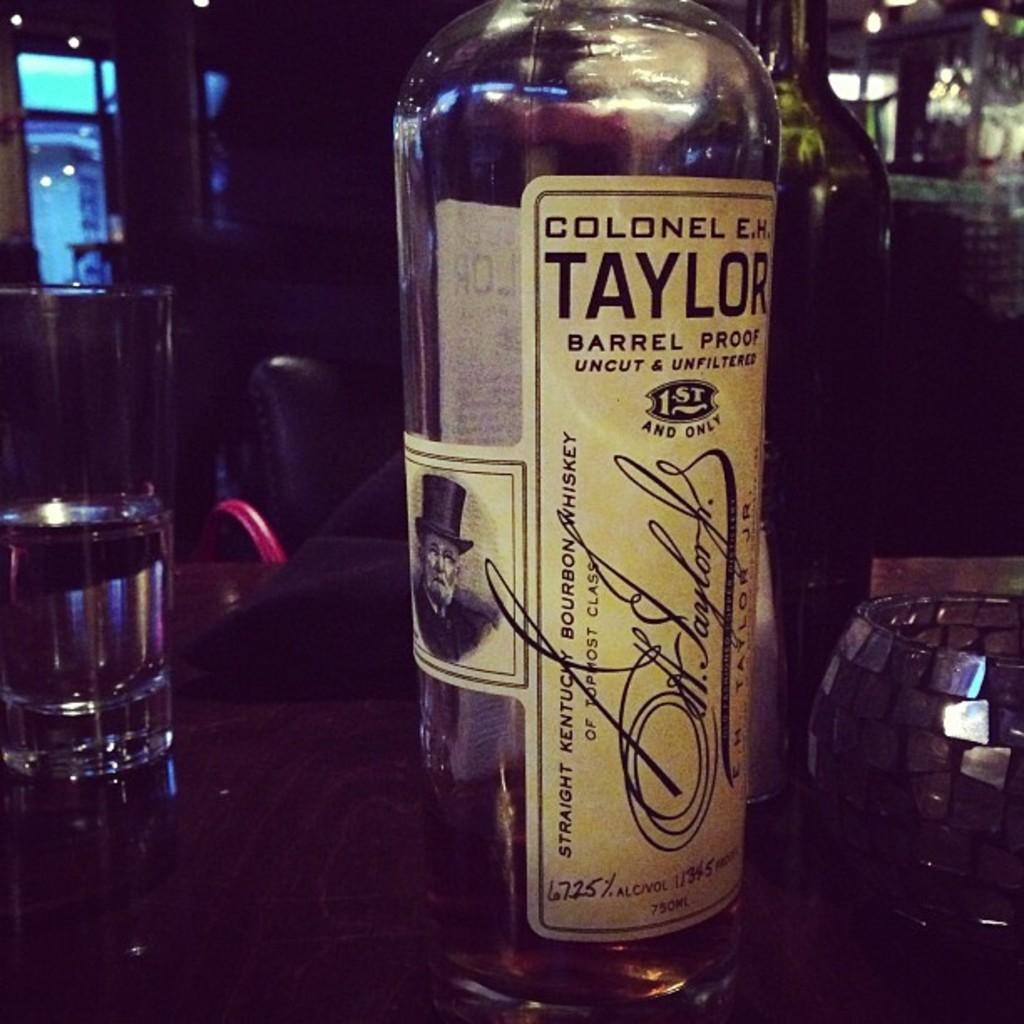What is on the label of the bottle in the image? The facts do not specify what is on the label of the bottle. Where is the bottle located in the image? The bottle is on a table in the image. What is in the glass that is visible in the image? There is water in the glass in the image. Where is the glass located in the image? The glass is on a table in the image. What type of drug is being administered through the bottle in the image? There is no drug present in the image; it is a bottle with a label and a glass with water. How many snakes are visible in the image? There are no snakes present in the image. 